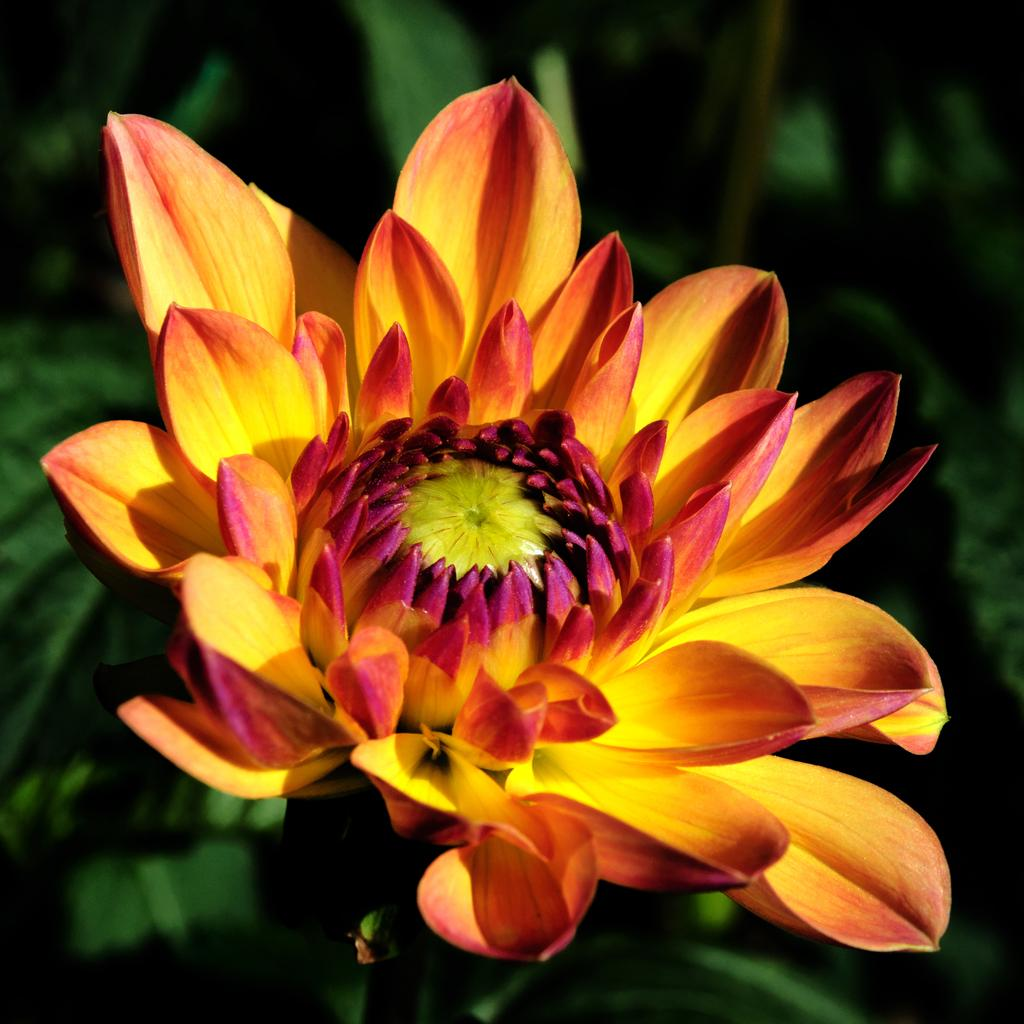What is the main subject of the image? There is a flower in the image. Can you describe the colors of the flower? The flower has yellow and orange colors. How would you describe the background of the image? The background of the image is slightly blurred. What type of vegetation can be seen in the background? Green leaves are visible in the background of the image. What type of pets are visible in the image? There are no pets present in the image; it features a flower with green leaves in the background. What historical event is depicted in the image? There is no historical event depicted in the image; it features a flower with green leaves in the background. 